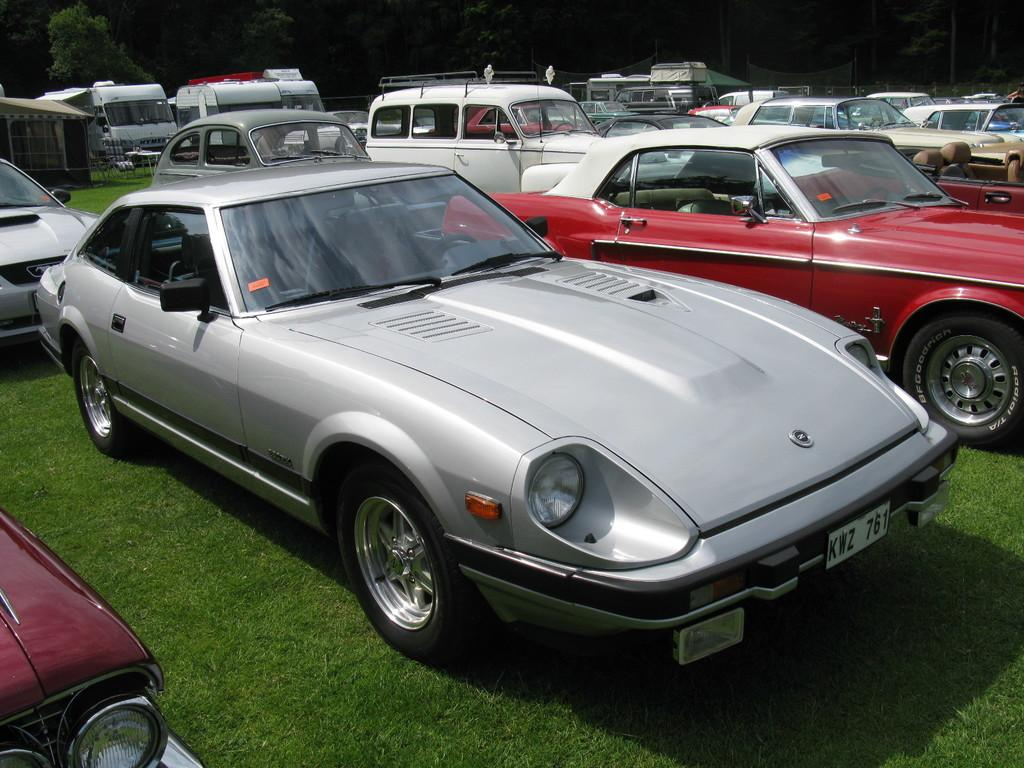What type of vehicles are present in the image? There are many cars in the image. Can you describe the colors of the cars? The cars are of different colors. What other types of vehicles can be seen in the background? There are vans in the background of the image. What natural elements are visible in the background? There are trees in the background of the image. What is the ground surface like at the bottom of the image? There is grass at the bottom of the image. What effect does the thunder have on the cars in the image? There is no thunder present in the image, so no such effect can be observed. 